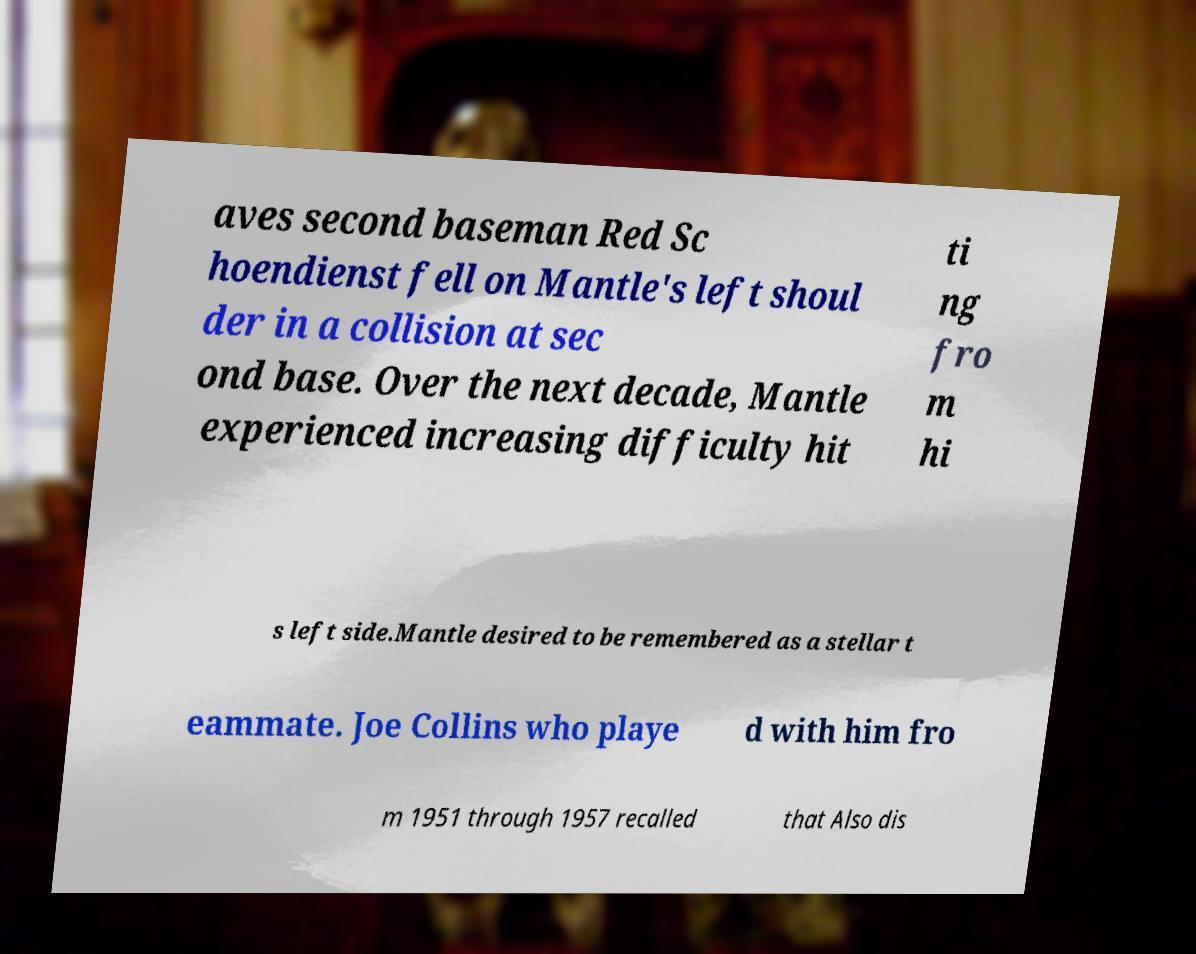Could you extract and type out the text from this image? aves second baseman Red Sc hoendienst fell on Mantle's left shoul der in a collision at sec ond base. Over the next decade, Mantle experienced increasing difficulty hit ti ng fro m hi s left side.Mantle desired to be remembered as a stellar t eammate. Joe Collins who playe d with him fro m 1951 through 1957 recalled that Also dis 